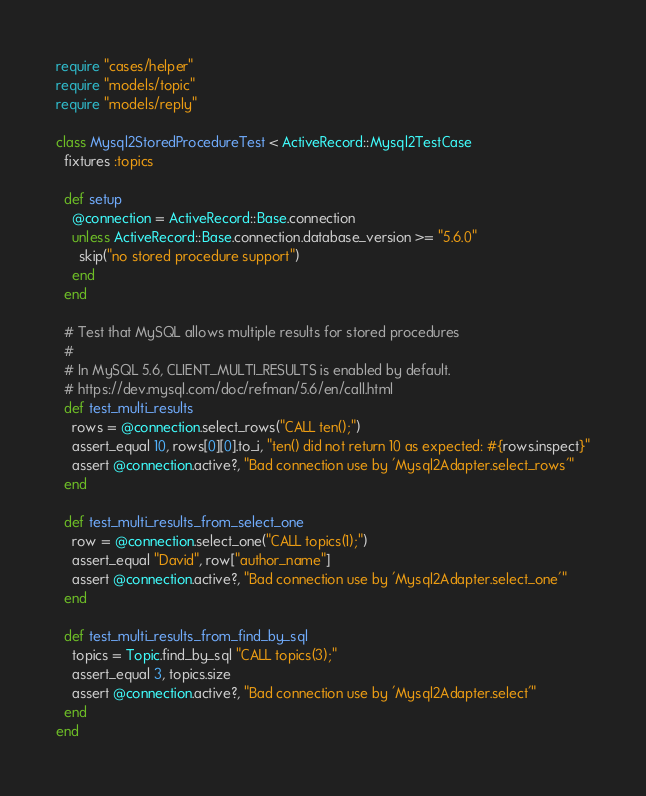<code> <loc_0><loc_0><loc_500><loc_500><_Ruby_>
require "cases/helper"
require "models/topic"
require "models/reply"

class Mysql2StoredProcedureTest < ActiveRecord::Mysql2TestCase
  fixtures :topics

  def setup
    @connection = ActiveRecord::Base.connection
    unless ActiveRecord::Base.connection.database_version >= "5.6.0"
      skip("no stored procedure support")
    end
  end

  # Test that MySQL allows multiple results for stored procedures
  #
  # In MySQL 5.6, CLIENT_MULTI_RESULTS is enabled by default.
  # https://dev.mysql.com/doc/refman/5.6/en/call.html
  def test_multi_results
    rows = @connection.select_rows("CALL ten();")
    assert_equal 10, rows[0][0].to_i, "ten() did not return 10 as expected: #{rows.inspect}"
    assert @connection.active?, "Bad connection use by 'Mysql2Adapter.select_rows'"
  end

  def test_multi_results_from_select_one
    row = @connection.select_one("CALL topics(1);")
    assert_equal "David", row["author_name"]
    assert @connection.active?, "Bad connection use by 'Mysql2Adapter.select_one'"
  end

  def test_multi_results_from_find_by_sql
    topics = Topic.find_by_sql "CALL topics(3);"
    assert_equal 3, topics.size
    assert @connection.active?, "Bad connection use by 'Mysql2Adapter.select'"
  end
end
</code> 